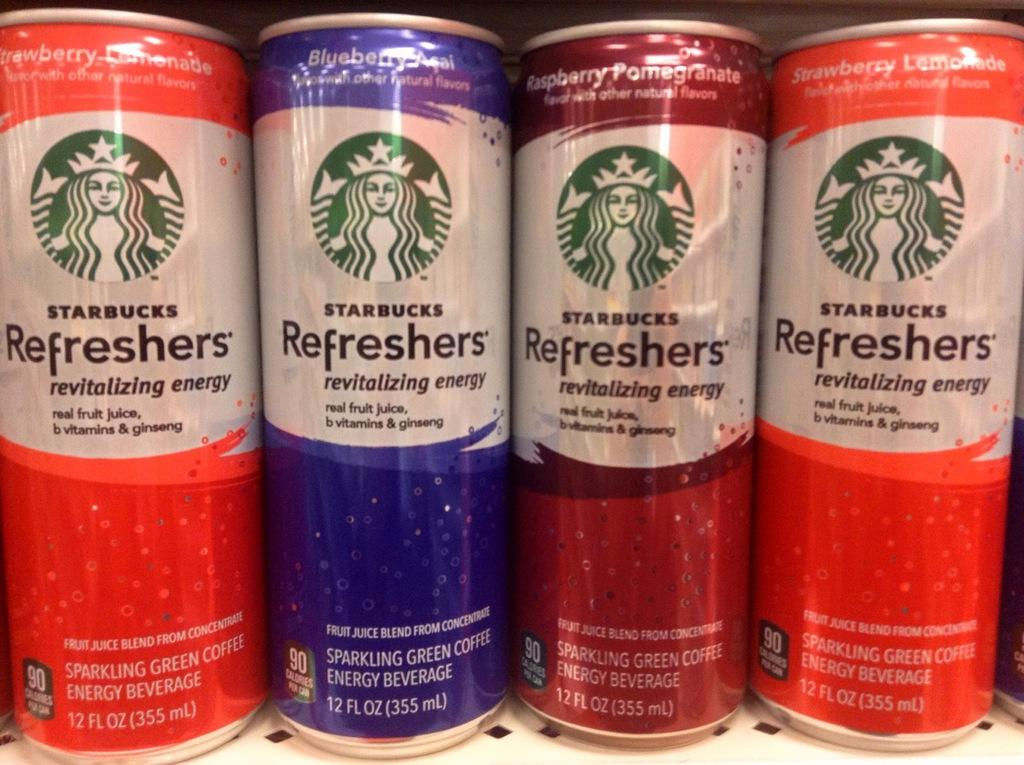<image>
Offer a succinct explanation of the picture presented. Several cans of Starbucks refreshers are lined up on a store shelf. 